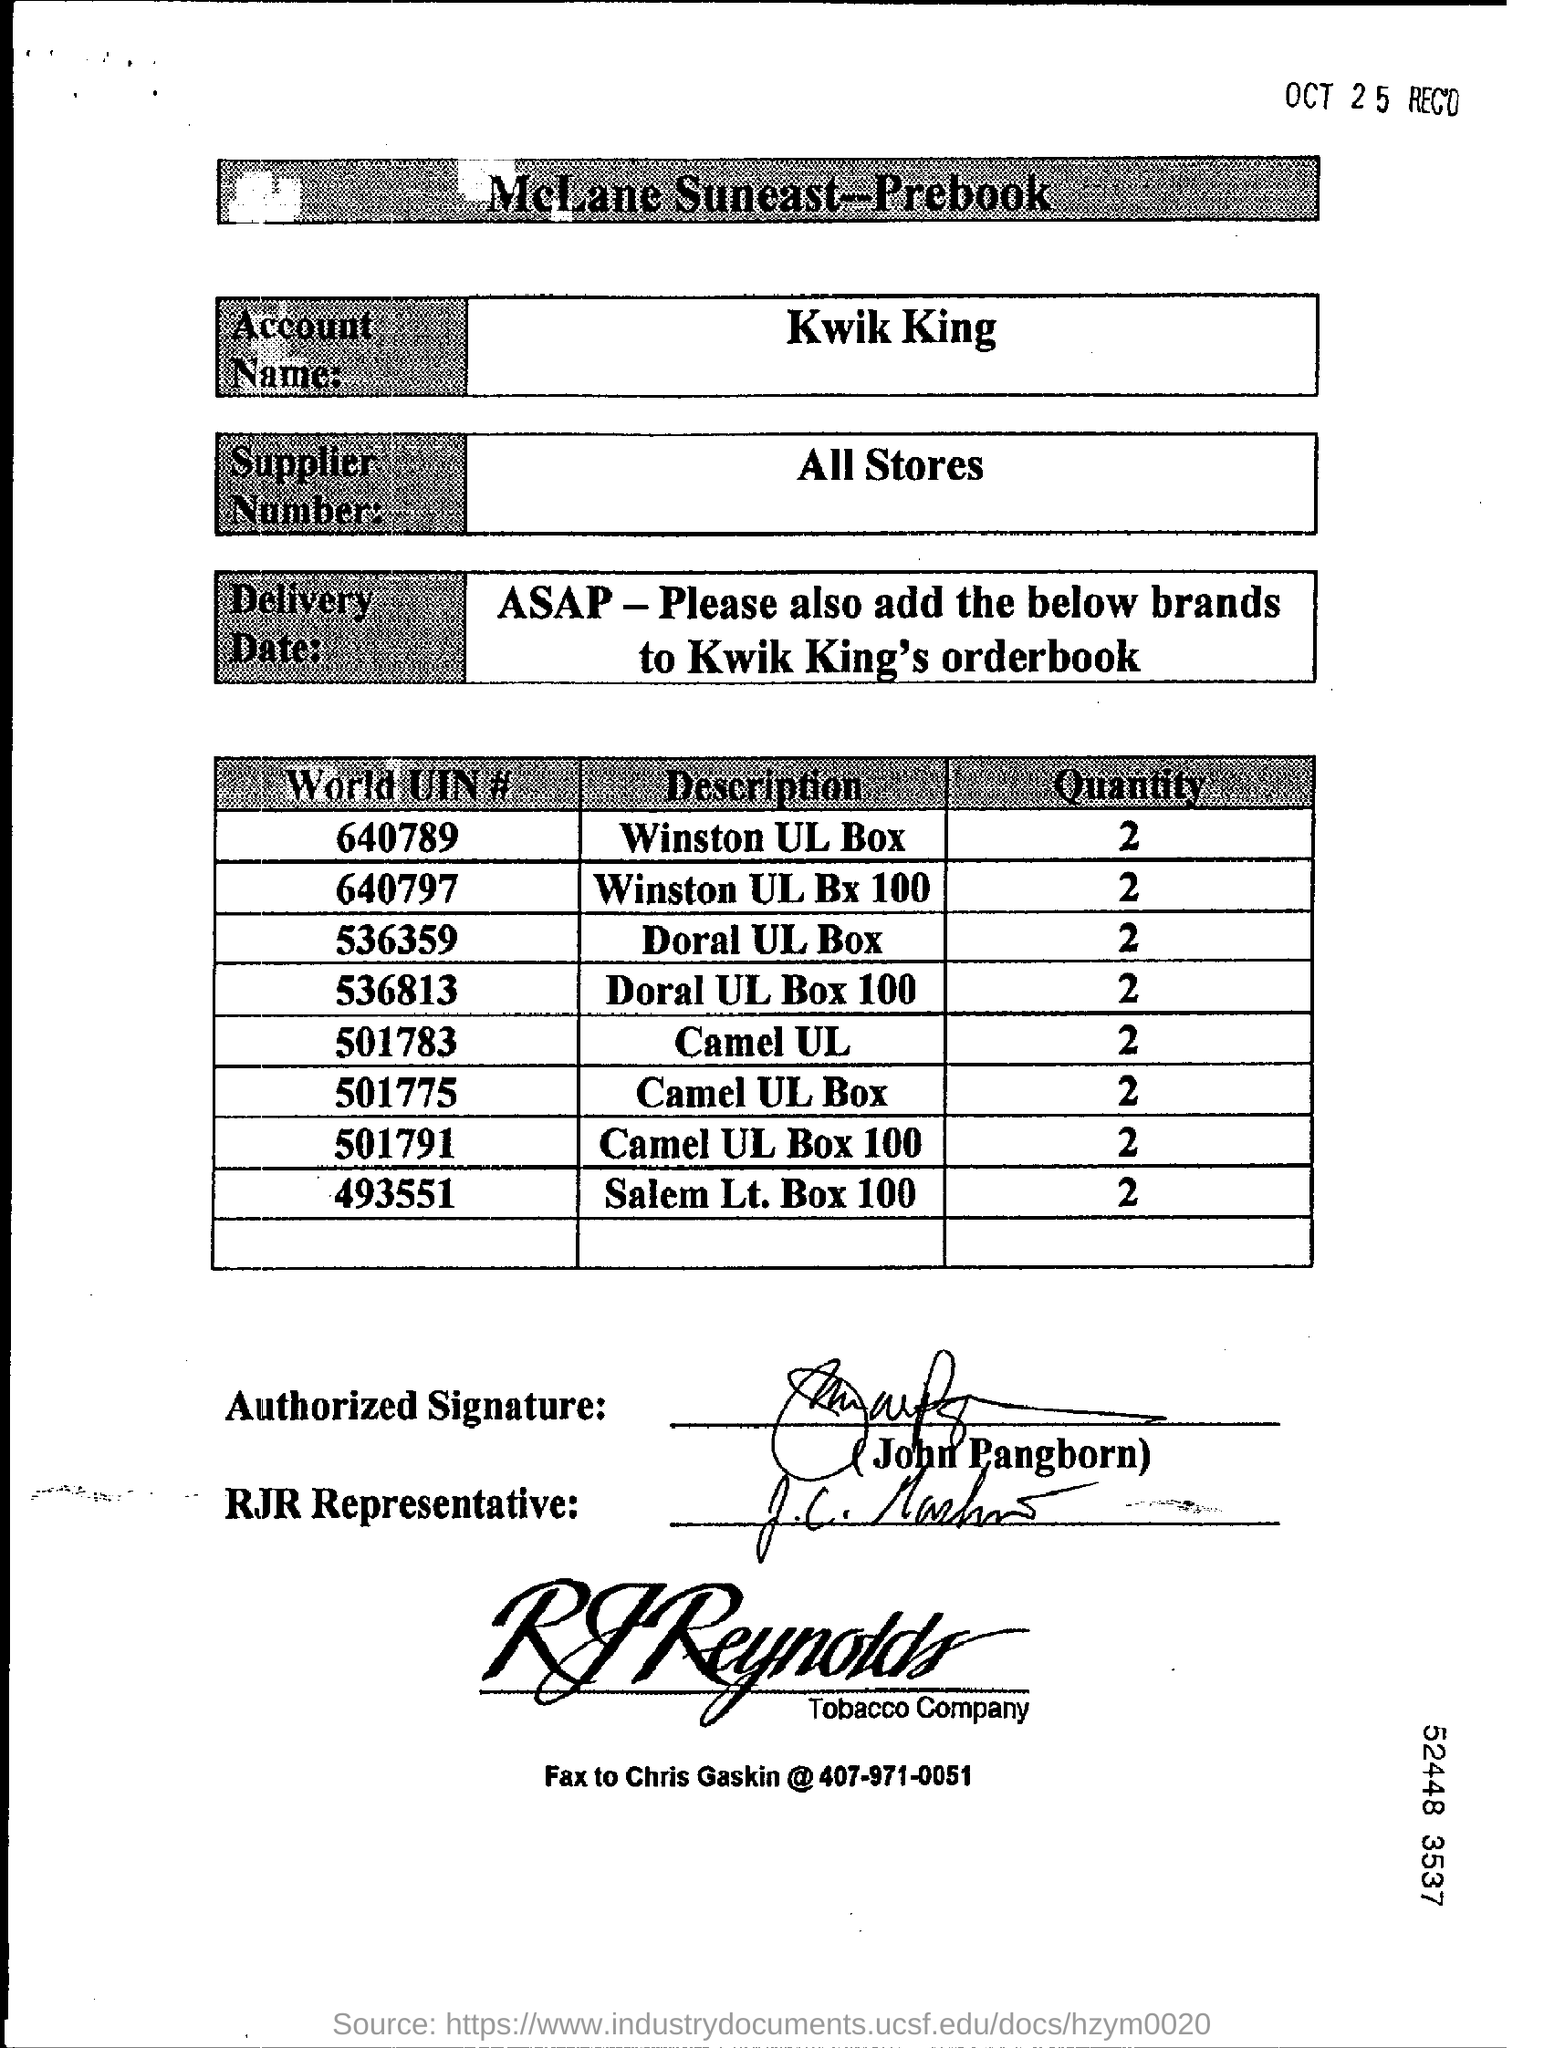Specify some key components in this picture. The world UIN number of the Doral UL box is 536359... The fax number is 407-971-0051. The account name is Kwik King. The World UIN Number of Camel UL Box 100 is 501791. The quantity of Camel UL is 2. 